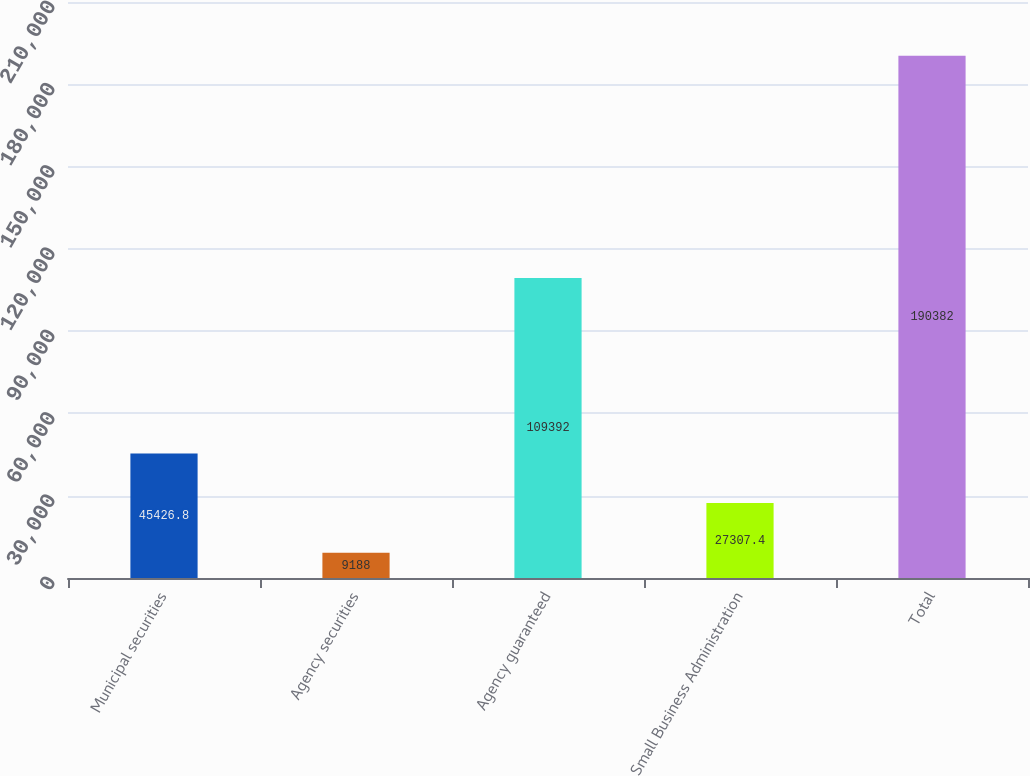Convert chart. <chart><loc_0><loc_0><loc_500><loc_500><bar_chart><fcel>Municipal securities<fcel>Agency securities<fcel>Agency guaranteed<fcel>Small Business Administration<fcel>Total<nl><fcel>45426.8<fcel>9188<fcel>109392<fcel>27307.4<fcel>190382<nl></chart> 